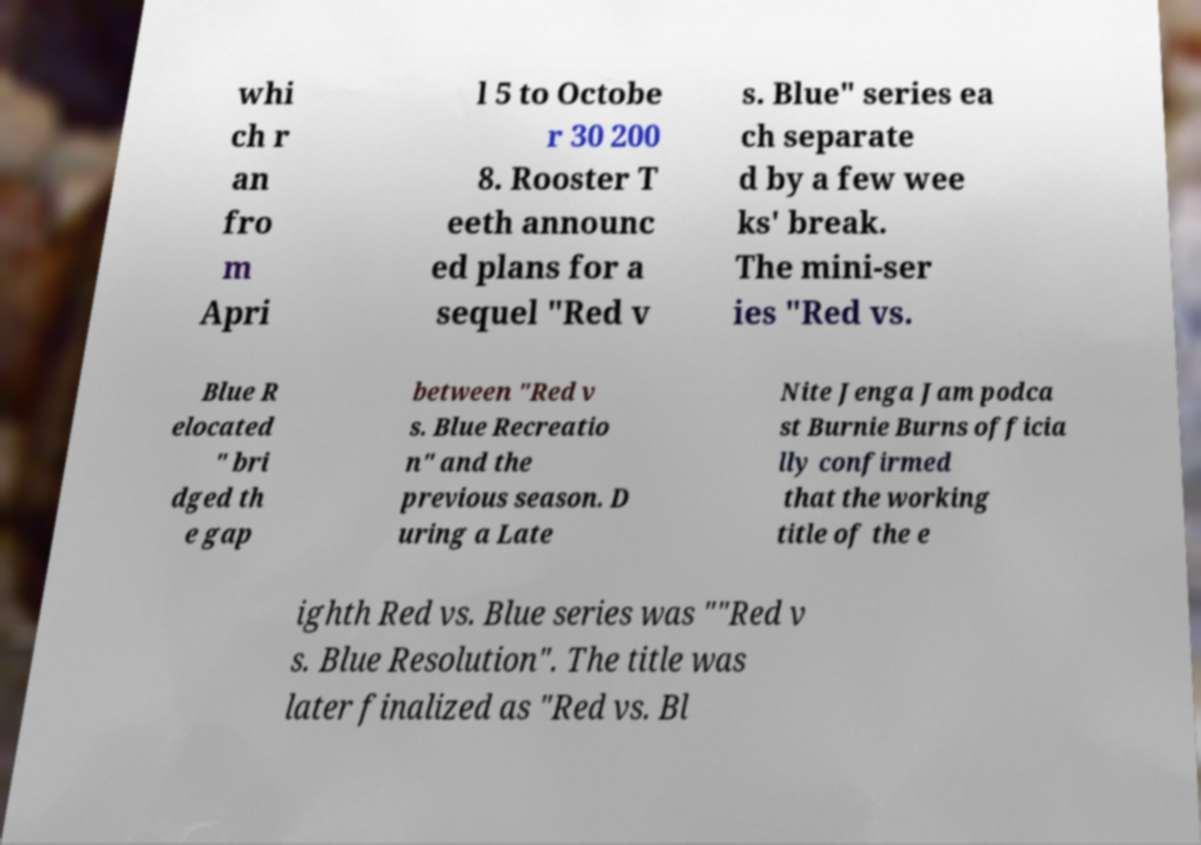Please read and relay the text visible in this image. What does it say? whi ch r an fro m Apri l 5 to Octobe r 30 200 8. Rooster T eeth announc ed plans for a sequel "Red v s. Blue" series ea ch separate d by a few wee ks' break. The mini-ser ies "Red vs. Blue R elocated " bri dged th e gap between "Red v s. Blue Recreatio n" and the previous season. D uring a Late Nite Jenga Jam podca st Burnie Burns officia lly confirmed that the working title of the e ighth Red vs. Blue series was ""Red v s. Blue Resolution". The title was later finalized as "Red vs. Bl 